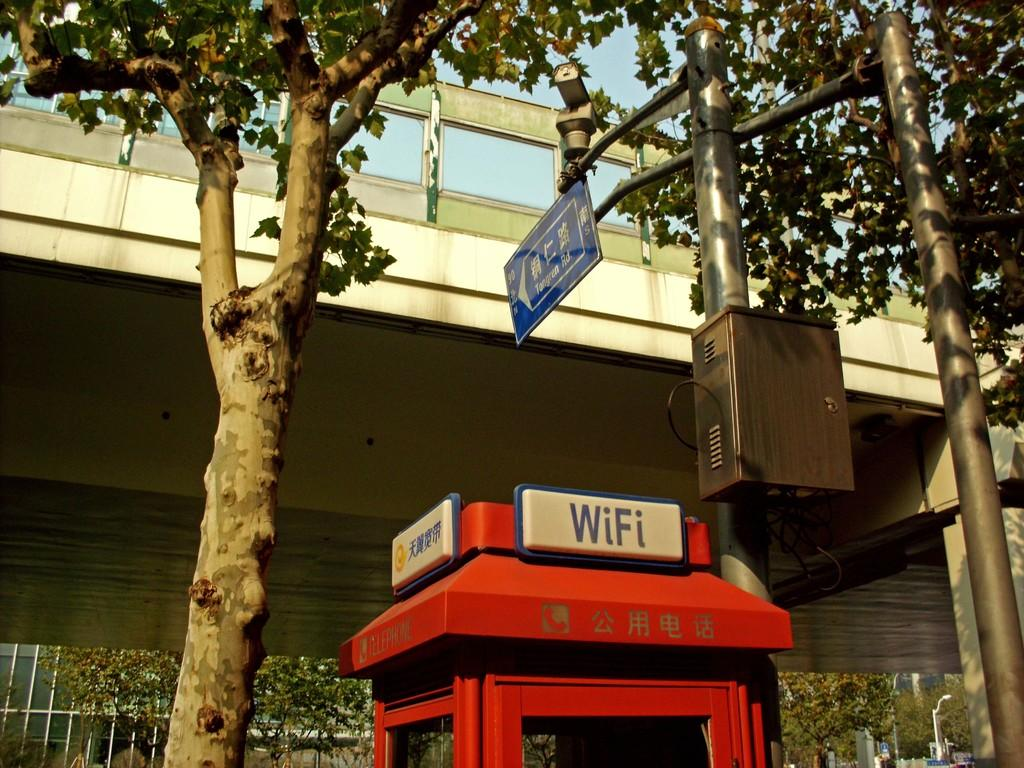<image>
Write a terse but informative summary of the picture. The red box shown here is advertising Wi-fi. 